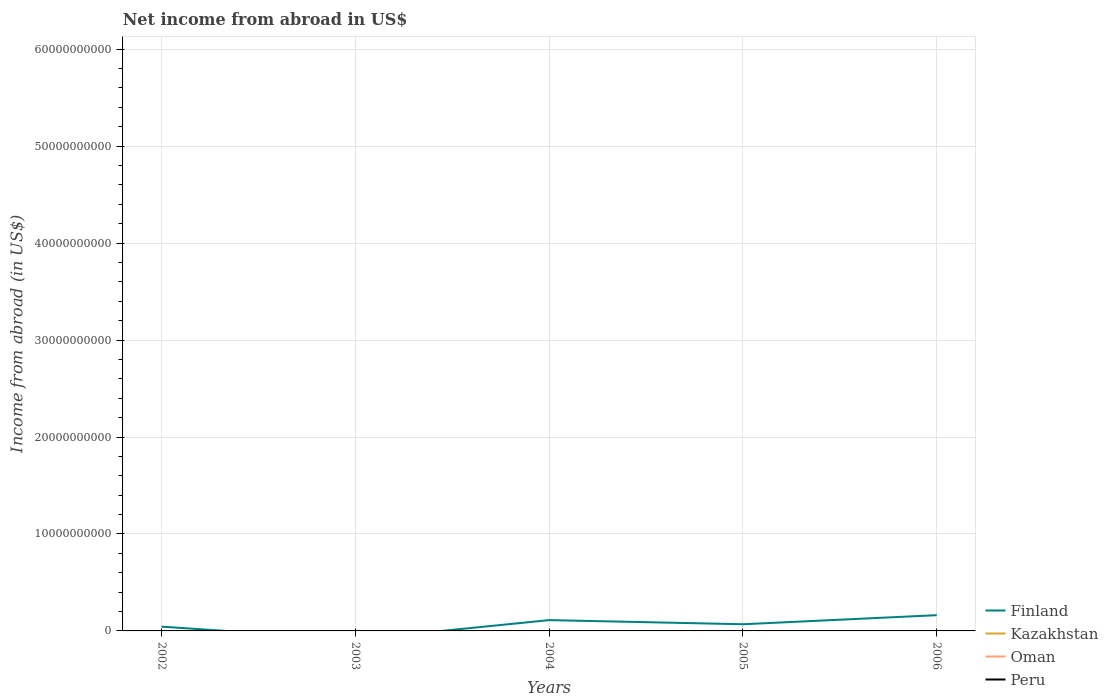Is the number of lines equal to the number of legend labels?
Your answer should be very brief. No. What is the total net income from abroad in Finland in the graph?
Ensure brevity in your answer.  -5.09e+08. What is the difference between the highest and the second highest net income from abroad in Finland?
Provide a short and direct response. 1.62e+09. How many lines are there?
Your answer should be compact. 1. How many years are there in the graph?
Offer a terse response. 5. What is the difference between two consecutive major ticks on the Y-axis?
Provide a succinct answer. 1.00e+1. Are the values on the major ticks of Y-axis written in scientific E-notation?
Offer a terse response. No. Does the graph contain any zero values?
Your response must be concise. Yes. How are the legend labels stacked?
Your answer should be very brief. Vertical. What is the title of the graph?
Offer a very short reply. Net income from abroad in US$. What is the label or title of the X-axis?
Offer a terse response. Years. What is the label or title of the Y-axis?
Give a very brief answer. Income from abroad (in US$). What is the Income from abroad (in US$) in Finland in 2002?
Provide a short and direct response. 4.42e+08. What is the Income from abroad (in US$) in Oman in 2002?
Make the answer very short. 0. What is the Income from abroad (in US$) of Peru in 2002?
Provide a succinct answer. 0. What is the Income from abroad (in US$) of Oman in 2003?
Give a very brief answer. 0. What is the Income from abroad (in US$) of Finland in 2004?
Your answer should be very brief. 1.12e+09. What is the Income from abroad (in US$) of Oman in 2004?
Offer a very short reply. 0. What is the Income from abroad (in US$) of Peru in 2004?
Offer a terse response. 0. What is the Income from abroad (in US$) of Finland in 2005?
Provide a succinct answer. 6.88e+08. What is the Income from abroad (in US$) in Kazakhstan in 2005?
Give a very brief answer. 0. What is the Income from abroad (in US$) in Oman in 2005?
Offer a terse response. 0. What is the Income from abroad (in US$) in Peru in 2005?
Your answer should be compact. 0. What is the Income from abroad (in US$) of Finland in 2006?
Provide a short and direct response. 1.62e+09. What is the Income from abroad (in US$) in Oman in 2006?
Offer a very short reply. 0. Across all years, what is the maximum Income from abroad (in US$) in Finland?
Give a very brief answer. 1.62e+09. What is the total Income from abroad (in US$) in Finland in the graph?
Provide a short and direct response. 3.87e+09. What is the total Income from abroad (in US$) of Kazakhstan in the graph?
Offer a terse response. 0. What is the difference between the Income from abroad (in US$) in Finland in 2002 and that in 2004?
Keep it short and to the point. -6.73e+08. What is the difference between the Income from abroad (in US$) of Finland in 2002 and that in 2005?
Provide a succinct answer. -2.46e+08. What is the difference between the Income from abroad (in US$) in Finland in 2002 and that in 2006?
Your answer should be very brief. -1.18e+09. What is the difference between the Income from abroad (in US$) of Finland in 2004 and that in 2005?
Offer a terse response. 4.27e+08. What is the difference between the Income from abroad (in US$) in Finland in 2004 and that in 2006?
Offer a terse response. -5.09e+08. What is the difference between the Income from abroad (in US$) in Finland in 2005 and that in 2006?
Offer a very short reply. -9.36e+08. What is the average Income from abroad (in US$) of Finland per year?
Your answer should be compact. 7.74e+08. What is the average Income from abroad (in US$) in Peru per year?
Offer a terse response. 0. What is the ratio of the Income from abroad (in US$) in Finland in 2002 to that in 2004?
Offer a terse response. 0.4. What is the ratio of the Income from abroad (in US$) in Finland in 2002 to that in 2005?
Your response must be concise. 0.64. What is the ratio of the Income from abroad (in US$) in Finland in 2002 to that in 2006?
Keep it short and to the point. 0.27. What is the ratio of the Income from abroad (in US$) of Finland in 2004 to that in 2005?
Offer a very short reply. 1.62. What is the ratio of the Income from abroad (in US$) in Finland in 2004 to that in 2006?
Keep it short and to the point. 0.69. What is the ratio of the Income from abroad (in US$) of Finland in 2005 to that in 2006?
Keep it short and to the point. 0.42. What is the difference between the highest and the second highest Income from abroad (in US$) in Finland?
Offer a very short reply. 5.09e+08. What is the difference between the highest and the lowest Income from abroad (in US$) of Finland?
Ensure brevity in your answer.  1.62e+09. 